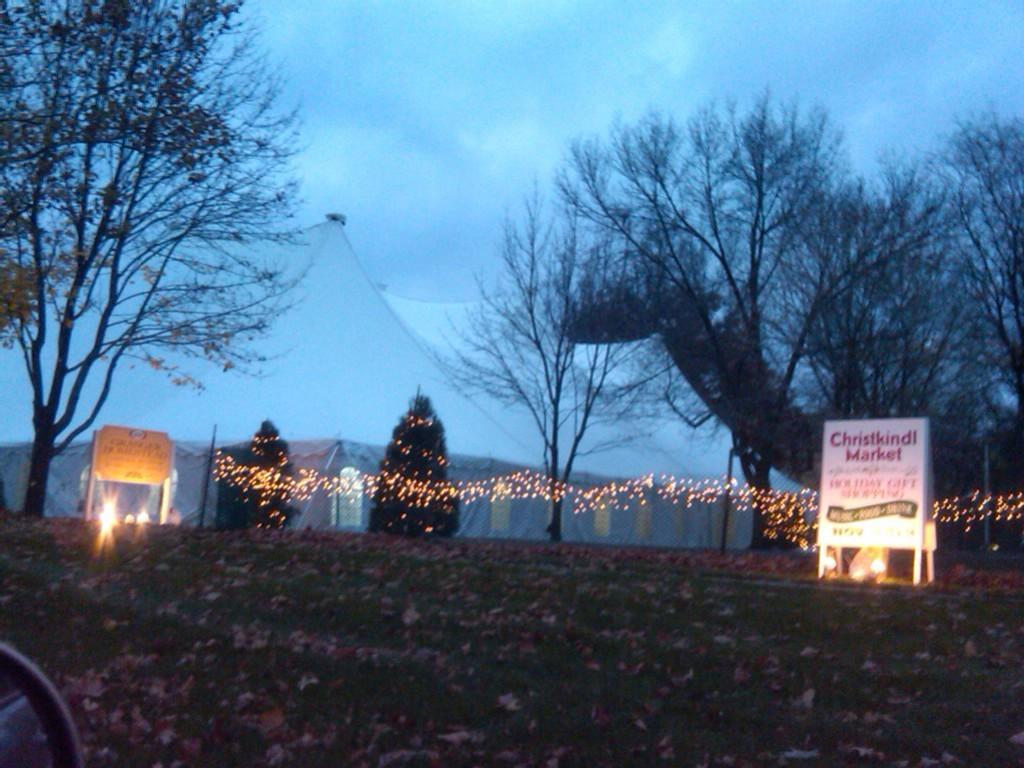Please provide a concise description of this image. In this image we can see grass, dried leaves, boards, lights, poles, trees, and tents. In the background there is sky with clouds. 